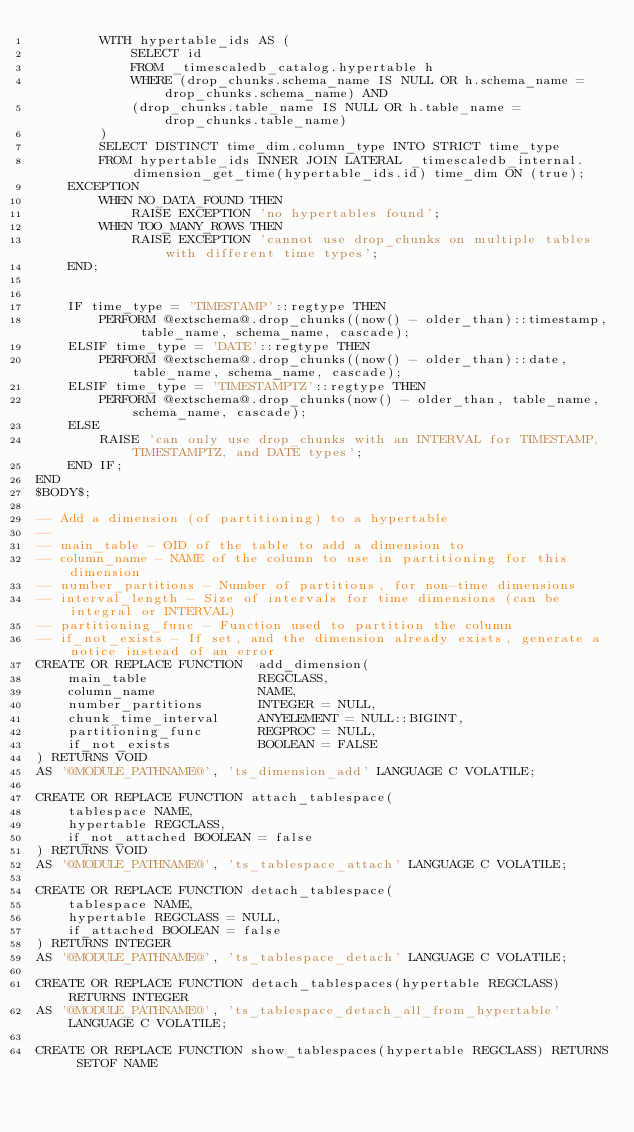<code> <loc_0><loc_0><loc_500><loc_500><_SQL_>        WITH hypertable_ids AS (
            SELECT id
            FROM _timescaledb_catalog.hypertable h
            WHERE (drop_chunks.schema_name IS NULL OR h.schema_name = drop_chunks.schema_name) AND
            (drop_chunks.table_name IS NULL OR h.table_name = drop_chunks.table_name)
        )
        SELECT DISTINCT time_dim.column_type INTO STRICT time_type
        FROM hypertable_ids INNER JOIN LATERAL _timescaledb_internal.dimension_get_time(hypertable_ids.id) time_dim ON (true);
    EXCEPTION
        WHEN NO_DATA_FOUND THEN
            RAISE EXCEPTION 'no hypertables found';
        WHEN TOO_MANY_ROWS THEN
            RAISE EXCEPTION 'cannot use drop_chunks on multiple tables with different time types';
    END;


    IF time_type = 'TIMESTAMP'::regtype THEN
        PERFORM @extschema@.drop_chunks((now() - older_than)::timestamp, table_name, schema_name, cascade);
    ELSIF time_type = 'DATE'::regtype THEN
        PERFORM @extschema@.drop_chunks((now() - older_than)::date, table_name, schema_name, cascade);
    ELSIF time_type = 'TIMESTAMPTZ'::regtype THEN
        PERFORM @extschema@.drop_chunks(now() - older_than, table_name, schema_name, cascade);
    ELSE
        RAISE 'can only use drop_chunks with an INTERVAL for TIMESTAMP, TIMESTAMPTZ, and DATE types';
    END IF;
END
$BODY$;

-- Add a dimension (of partitioning) to a hypertable
--
-- main_table - OID of the table to add a dimension to
-- column_name - NAME of the column to use in partitioning for this dimension
-- number_partitions - Number of partitions, for non-time dimensions
-- interval_length - Size of intervals for time dimensions (can be integral or INTERVAL)
-- partitioning_func - Function used to partition the column
-- if_not_exists - If set, and the dimension already exists, generate a notice instead of an error
CREATE OR REPLACE FUNCTION  add_dimension(
    main_table              REGCLASS,
    column_name             NAME,
    number_partitions       INTEGER = NULL,
    chunk_time_interval     ANYELEMENT = NULL::BIGINT,
    partitioning_func       REGPROC = NULL,
    if_not_exists           BOOLEAN = FALSE
) RETURNS VOID
AS '@MODULE_PATHNAME@', 'ts_dimension_add' LANGUAGE C VOLATILE;

CREATE OR REPLACE FUNCTION attach_tablespace(
    tablespace NAME,
    hypertable REGCLASS,
    if_not_attached BOOLEAN = false
) RETURNS VOID
AS '@MODULE_PATHNAME@', 'ts_tablespace_attach' LANGUAGE C VOLATILE;

CREATE OR REPLACE FUNCTION detach_tablespace(
    tablespace NAME,
    hypertable REGCLASS = NULL,
    if_attached BOOLEAN = false
) RETURNS INTEGER
AS '@MODULE_PATHNAME@', 'ts_tablespace_detach' LANGUAGE C VOLATILE;

CREATE OR REPLACE FUNCTION detach_tablespaces(hypertable REGCLASS) RETURNS INTEGER
AS '@MODULE_PATHNAME@', 'ts_tablespace_detach_all_from_hypertable' LANGUAGE C VOLATILE;

CREATE OR REPLACE FUNCTION show_tablespaces(hypertable REGCLASS) RETURNS SETOF NAME</code> 